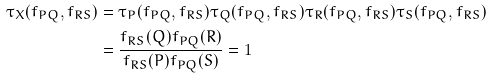Convert formula to latex. <formula><loc_0><loc_0><loc_500><loc_500>\tau _ { X } ( f _ { P Q } , f _ { R S } ) & = \tau _ { P } ( f _ { P Q } , f _ { R S } ) \tau _ { Q } ( f _ { P Q } , f _ { R S } ) \tau _ { R } ( f _ { P Q } , f _ { R S } ) \tau _ { S } ( f _ { P Q } , f _ { R S } ) \\ & = \frac { f _ { R S } ( Q ) f _ { P Q } ( R ) } { f _ { R S } ( P ) f _ { P Q } ( S ) } = 1</formula> 